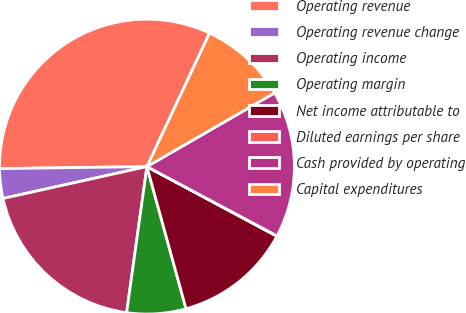Convert chart. <chart><loc_0><loc_0><loc_500><loc_500><pie_chart><fcel>Operating revenue<fcel>Operating revenue change<fcel>Operating income<fcel>Operating margin<fcel>Net income attributable to<fcel>Diluted earnings per share<fcel>Cash provided by operating<fcel>Capital expenditures<nl><fcel>32.2%<fcel>3.25%<fcel>19.33%<fcel>6.47%<fcel>12.9%<fcel>0.04%<fcel>16.12%<fcel>9.69%<nl></chart> 